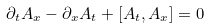<formula> <loc_0><loc_0><loc_500><loc_500>\partial _ { t } A _ { x } - \partial _ { x } A _ { t } + [ A _ { t } , A _ { x } ] = 0</formula> 